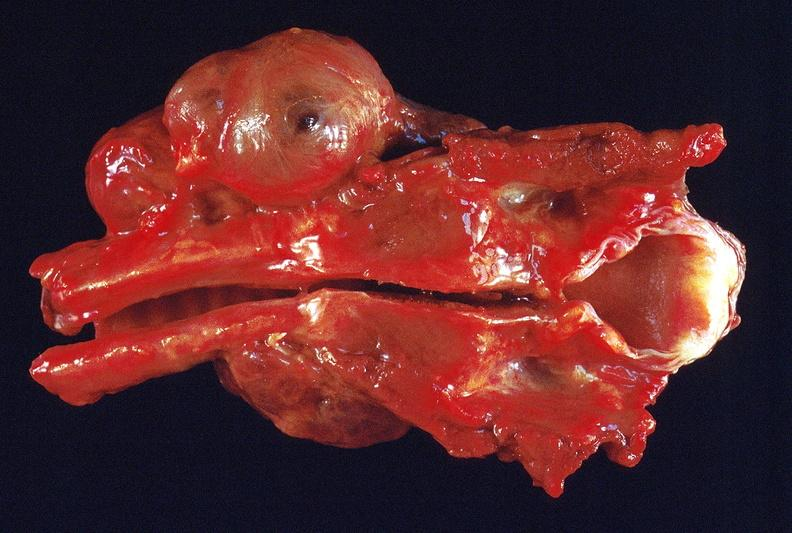what does this image show?
Answer the question using a single word or phrase. Thyroid 